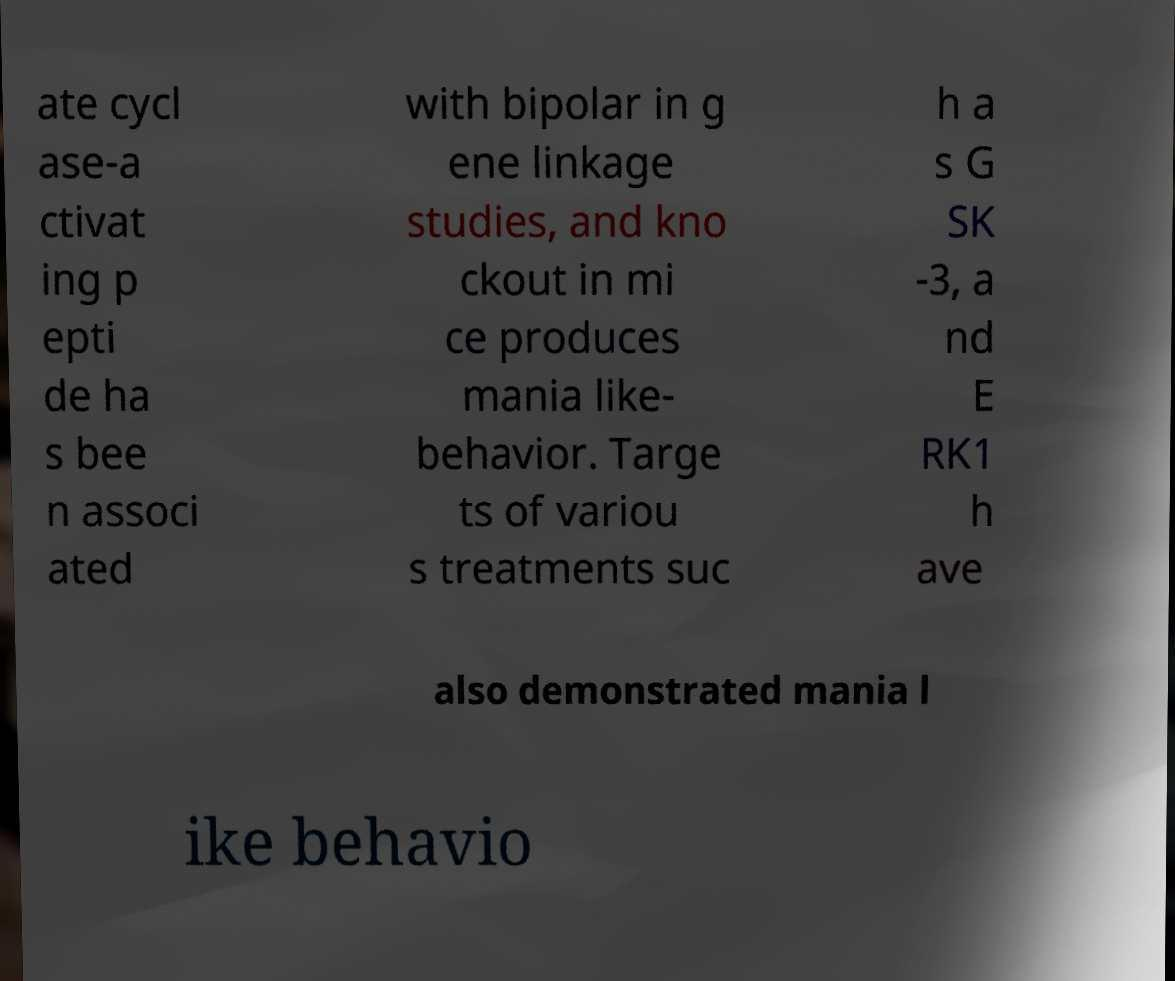What messages or text are displayed in this image? I need them in a readable, typed format. ate cycl ase-a ctivat ing p epti de ha s bee n associ ated with bipolar in g ene linkage studies, and kno ckout in mi ce produces mania like- behavior. Targe ts of variou s treatments suc h a s G SK -3, a nd E RK1 h ave also demonstrated mania l ike behavio 